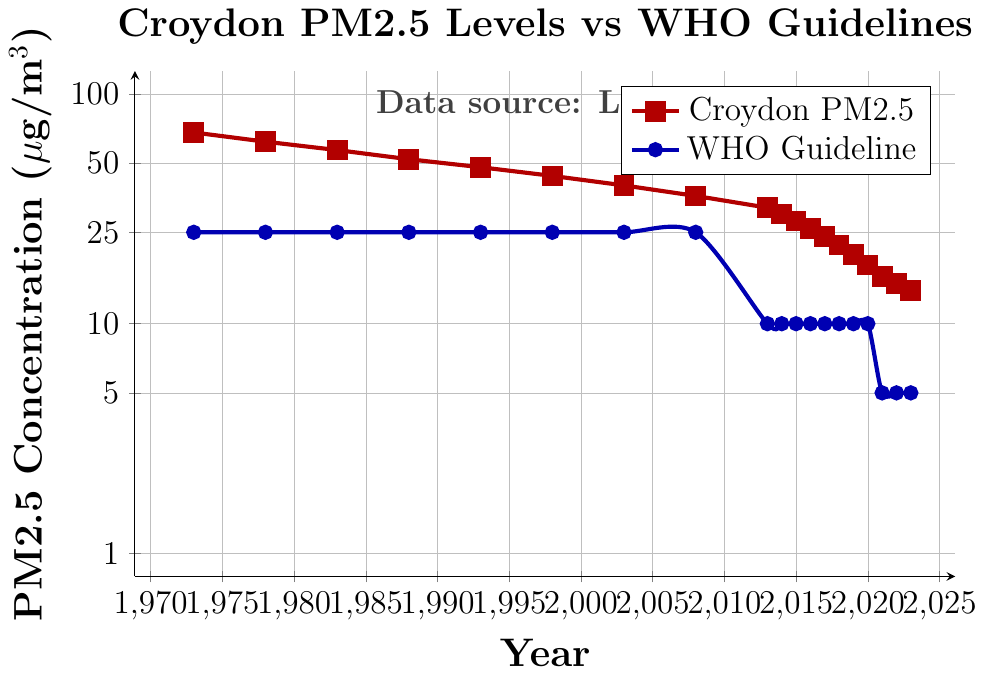How has Croydon's PM2.5 concentration changed from 1973 to 2023? From the chart, Croydon's PM2.5 concentration has decreased over the years from 68 µg/m³ in 1973 to 14 µg/m³ in 2023.
Answer: Decreased from 68 µg/m³ to 14 µg/m³ How do the PM2.5 levels in 2023 compare to the WHO guideline? The chart shows that in 2023, Croydon's PM2.5 levels are 14 µg/m³, while the WHO guideline is 5 µg/m³. Croydon's levels are higher than the WHO guideline.
Answer: Higher than the WHO guideline In which years did Croydon's PM2.5 concentration meet the WHO guideline? The chart indicates that Croydon’s PM2.5 concentrations never met the WHO guideline values from 1973 to 2023.
Answer: Never met What is the average PM2.5 concentration in Croydon from 2013 to 2023? The PM2.5 concentrations in Croydon from 2013 to 2023 are: 32, 30, 28, 26, 24, 22, 20, 18, 16, 15, 14 µg/m³. Sum these values: 32+30+28+26+24+22+20+18+16+15+14 = 245. Divide by the number of years (11): 245/11 = 22.27 µg/m³.
Answer: 22.27 µg/m³ Which year saw the largest reduction in PM2.5 concentration in Croydon? A significant reduction can be identified by examining the differences between consecutive years. From 2013 to 2014, the PM2.5 concentration dropped from 32 µg/m³ to 30 µg/m³, which is a reduction of 2 µg/m³. This pattern repeats in smaller reductions. The largest single-year drop appears from 1973 to 1978, dropping from 68 µg/m³ to 62 µg/m³, a reduction of 6 µg/m³.
Answer: From 1973 to 1978 How does the PM2.5 concentration in Croydon in 1988 compare to the WHO guideline at that time? In 1988, Croydon's PM2.5 concentration was at 52 µg/m³, while the WHO guideline remained constant at 25 µg/m³. Croydon's concentration was much higher than the guideline.
Answer: Higher than the WHO guideline What significant changes happened in WHO guidelines according to the chart? The WHO guidelines changed twice according to the chart: In 2013, they were reduced from 25 µg/m³ to 10 µg/m³, and again in 2021, they were further reduced from 10 µg/m³ to 5 µg/m³.
Answer: Reduced in 2013 and 2021 Compare the rate of decline in PM2.5 levels in Croydon before and after the year 2000. Before 2000, PM2.5 levels decreased from 68 µg/m³ in 1973 to 44 µg/m³ in 1998, a reduction of 24 µg/m³ over 25 years (0.96 µg/m³ per year). After 2000, levels decreased from 40 µg/m³ in 2003 to 14 µg/m³ in 2023, a reduction of 26 µg/m³ over 20 years (1.3 µg/m³ per year).
Answer: Faster reduction after 2000 What has been the trend in PM2.5 levels in Croydon after 2013 compared to the WHO guideline set in 2013? After 2013, Croydon's PM2.5 levels have decreased from 32 µg/m³ to 14 µg/m³ in 2023. The WHO guideline set in 2013 was 10 µg/m³ which was reached in 2017 and remained above even when the guideline was further reduced in 2021.
Answer: Croydon levels decreased but stayed above guidelines 